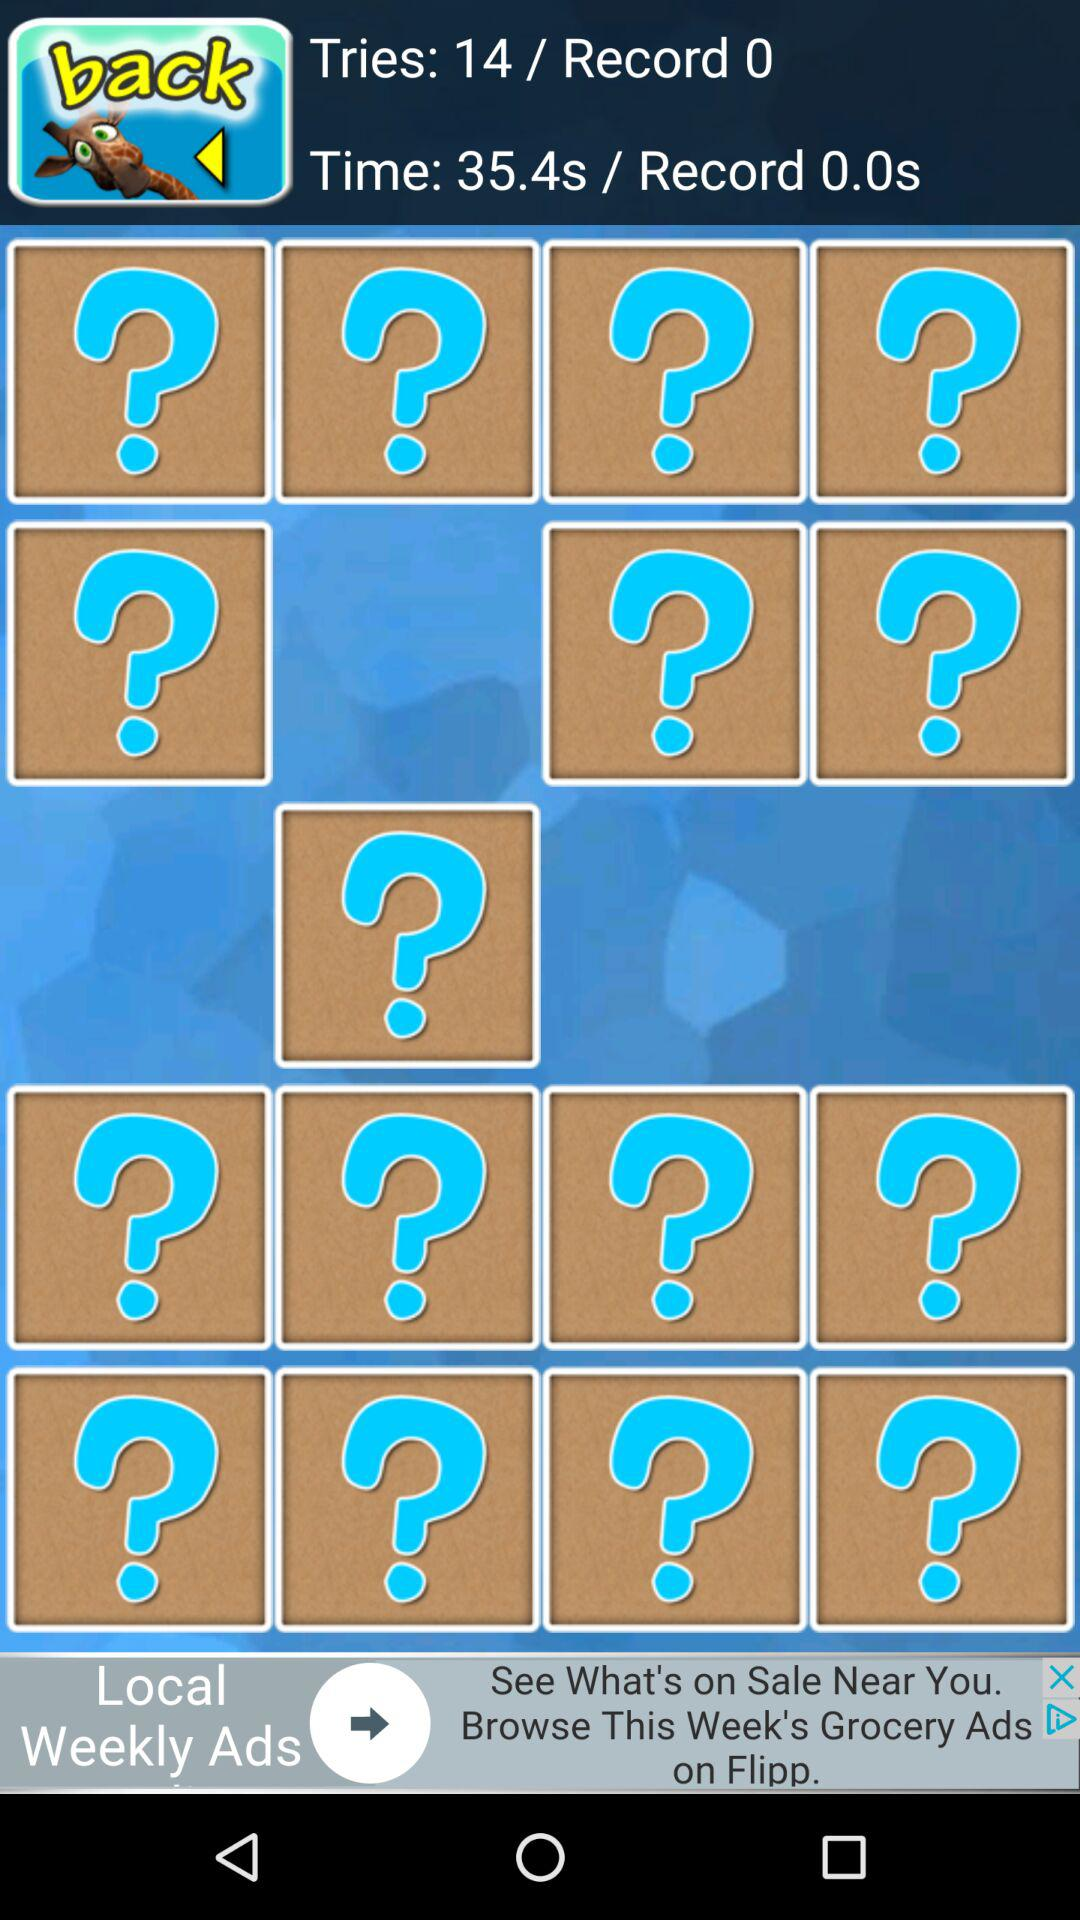What is the mentioned number of tries? The mentioned number of tries is 14. 